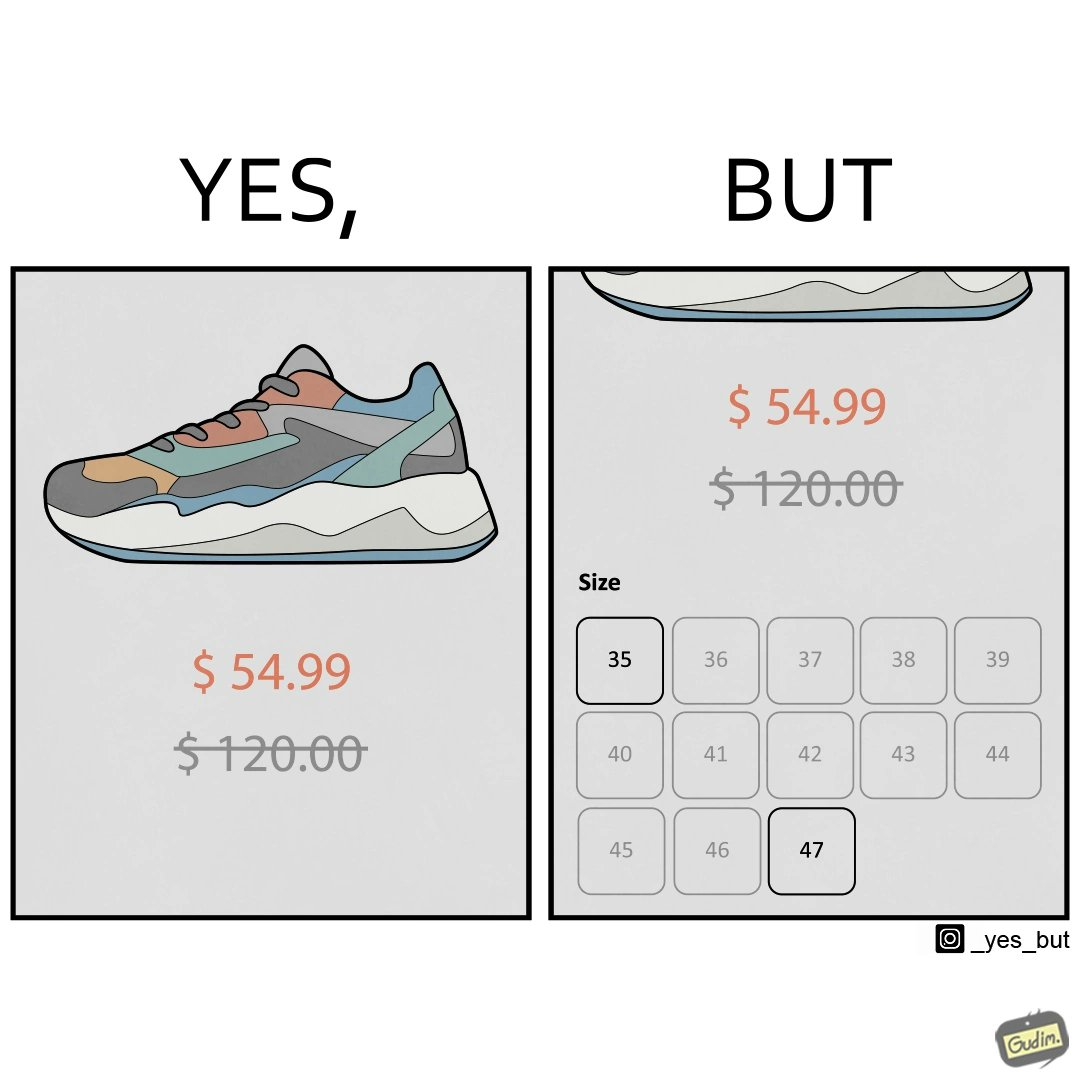What is the satirical meaning behind this image? The image is funny because while there is a big discount on the shoes inticing customer to buy them, the only available sizes are 35 and 47 which are the smalles and the largest meaning that a majority of the people can not buy the shoe because they won't fit. 